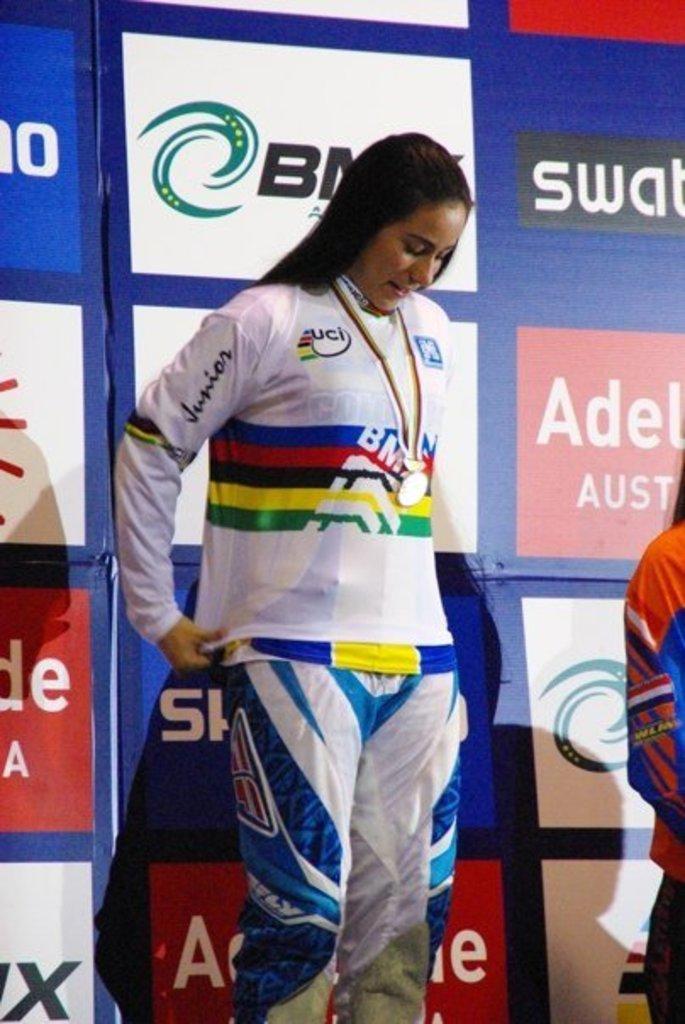What is written in the middle of the girls shirt?
Provide a short and direct response. Bm. What is written on the girl's arm?
Provide a short and direct response. Junior. 